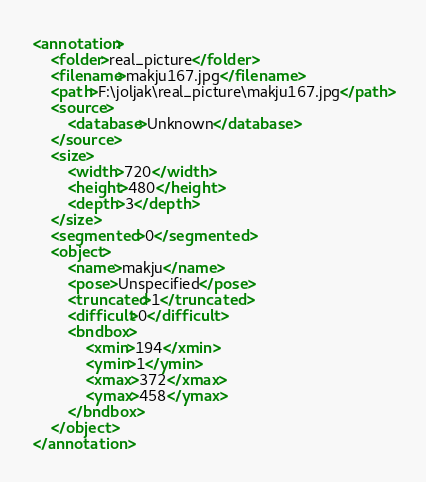<code> <loc_0><loc_0><loc_500><loc_500><_XML_><annotation>
	<folder>real_picture</folder>
	<filename>makju167.jpg</filename>
	<path>F:\joljak\real_picture\makju167.jpg</path>
	<source>
		<database>Unknown</database>
	</source>
	<size>
		<width>720</width>
		<height>480</height>
		<depth>3</depth>
	</size>
	<segmented>0</segmented>
	<object>
		<name>makju</name>
		<pose>Unspecified</pose>
		<truncated>1</truncated>
		<difficult>0</difficult>
		<bndbox>
			<xmin>194</xmin>
			<ymin>1</ymin>
			<xmax>372</xmax>
			<ymax>458</ymax>
		</bndbox>
	</object>
</annotation>
</code> 